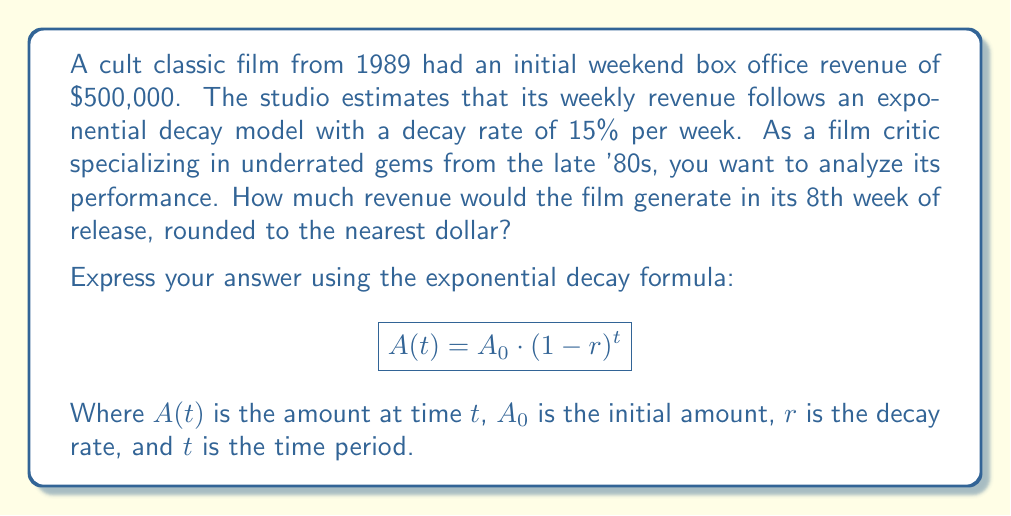Solve this math problem. To solve this problem, we'll use the exponential decay formula:

$$A(t) = A_0 \cdot (1-r)^t$$

Where:
$A(t)$ = Revenue in week 8
$A_0$ = Initial revenue ($500,000)
$r$ = Decay rate (15% or 0.15)
$t$ = Time period (8 weeks)

Let's plug in the values:

$$A(8) = 500,000 \cdot (1-0.15)^8$$

Now, let's calculate step by step:

1) First, calculate $(1-0.15)$:
   $(1-0.15) = 0.85$

2) Now, calculate $0.85^8$:
   $0.85^8 \approx 0.2725$

3) Finally, multiply by the initial revenue:
   $500,000 \cdot 0.2725 \approx 136,250$

Rounding to the nearest dollar, we get $136,250.
Answer: $A(8) = 500,000 \cdot (1-0.15)^8 \approx 136,250$ 